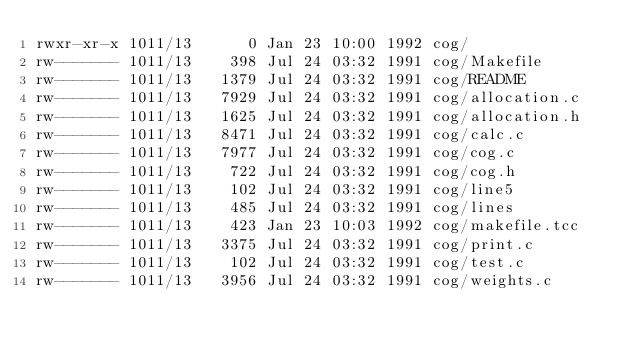Convert code to text. <code><loc_0><loc_0><loc_500><loc_500><_HTML_>rwxr-xr-x 1011/13      0 Jan 23 10:00 1992 cog/
rw------- 1011/13    398 Jul 24 03:32 1991 cog/Makefile
rw------- 1011/13   1379 Jul 24 03:32 1991 cog/README
rw------- 1011/13   7929 Jul 24 03:32 1991 cog/allocation.c
rw------- 1011/13   1625 Jul 24 03:32 1991 cog/allocation.h
rw------- 1011/13   8471 Jul 24 03:32 1991 cog/calc.c
rw------- 1011/13   7977 Jul 24 03:32 1991 cog/cog.c
rw------- 1011/13    722 Jul 24 03:32 1991 cog/cog.h
rw------- 1011/13    102 Jul 24 03:32 1991 cog/line5
rw------- 1011/13    485 Jul 24 03:32 1991 cog/lines
rw------- 1011/13    423 Jan 23 10:03 1992 cog/makefile.tcc
rw------- 1011/13   3375 Jul 24 03:32 1991 cog/print.c
rw------- 1011/13    102 Jul 24 03:32 1991 cog/test.c
rw------- 1011/13   3956 Jul 24 03:32 1991 cog/weights.c
</code> 